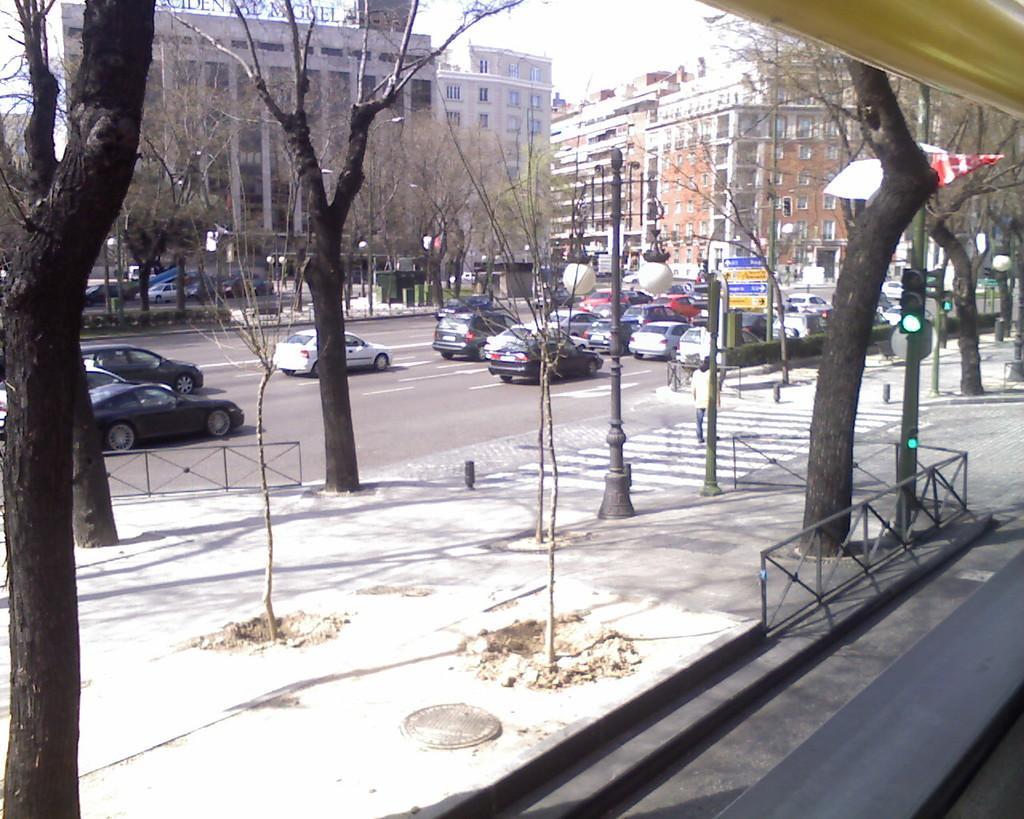In one or two sentences, can you explain what this image depicts? In this image I can see number of trees, few poles and few signal lights. In the background I can see number of cars on the road, few buildings and few more trees. In the background I can see few boards and on these words I can see something is written. 